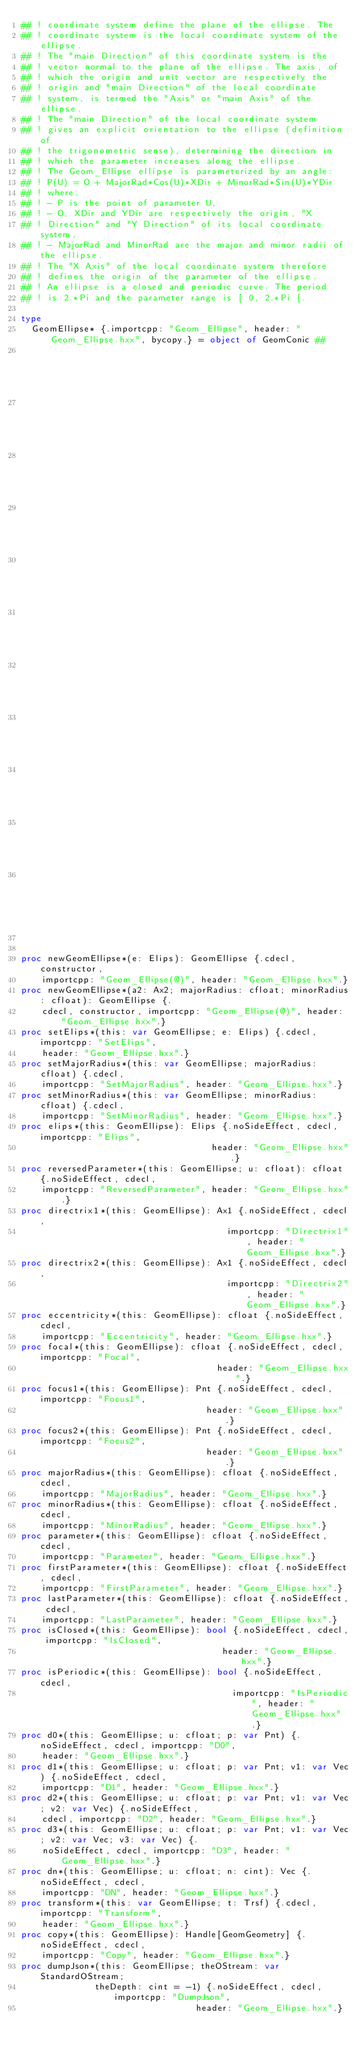<code> <loc_0><loc_0><loc_500><loc_500><_Nim_>## ! coordinate system define the plane of the ellipse. The
## ! coordinate system is the local coordinate system of the ellipse.
## ! The "main Direction" of this coordinate system is the
## ! vector normal to the plane of the ellipse. The axis, of
## ! which the origin and unit vector are respectively the
## ! origin and "main Direction" of the local coordinate
## ! system, is termed the "Axis" or "main Axis" of the ellipse.
## ! The "main Direction" of the local coordinate system
## ! gives an explicit orientation to the ellipse (definition of
## ! the trigonometric sense), determining the direction in
## ! which the parameter increases along the ellipse.
## ! The Geom_Ellipse ellipse is parameterized by an angle:
## ! P(U) = O + MajorRad*Cos(U)*XDir + MinorRad*Sin(U)*YDir
## ! where:
## ! - P is the point of parameter U,
## ! - O, XDir and YDir are respectively the origin, "X
## ! Direction" and "Y Direction" of its local coordinate system,
## ! - MajorRad and MinorRad are the major and minor radii of the ellipse.
## ! The "X Axis" of the local coordinate system therefore
## ! defines the origin of the parameter of the ellipse.
## ! An ellipse is a closed and periodic curve. The period
## ! is 2.*Pi and the parameter range is [ 0, 2.*Pi [.

type
  GeomEllipse* {.importcpp: "Geom_Ellipse", header: "Geom_Ellipse.hxx", bycopy.} = object of GeomConic ##
                                                                                             ## !
                                                                                             ## Constructs
                                                                                             ## an
                                                                                             ## ellipse
                                                                                             ## by
                                                                                             ## conversion
                                                                                             ## of
                                                                                             ## the
                                                                                             ## gp_Elips
                                                                                             ## ellipse
                                                                                             ## E.


proc newGeomEllipse*(e: Elips): GeomEllipse {.cdecl, constructor,
    importcpp: "Geom_Ellipse(@)", header: "Geom_Ellipse.hxx".}
proc newGeomEllipse*(a2: Ax2; majorRadius: cfloat; minorRadius: cfloat): GeomEllipse {.
    cdecl, constructor, importcpp: "Geom_Ellipse(@)", header: "Geom_Ellipse.hxx".}
proc setElips*(this: var GeomEllipse; e: Elips) {.cdecl, importcpp: "SetElips",
    header: "Geom_Ellipse.hxx".}
proc setMajorRadius*(this: var GeomEllipse; majorRadius: cfloat) {.cdecl,
    importcpp: "SetMajorRadius", header: "Geom_Ellipse.hxx".}
proc setMinorRadius*(this: var GeomEllipse; minorRadius: cfloat) {.cdecl,
    importcpp: "SetMinorRadius", header: "Geom_Ellipse.hxx".}
proc elips*(this: GeomEllipse): Elips {.noSideEffect, cdecl, importcpp: "Elips",
                                    header: "Geom_Ellipse.hxx".}
proc reversedParameter*(this: GeomEllipse; u: cfloat): cfloat {.noSideEffect, cdecl,
    importcpp: "ReversedParameter", header: "Geom_Ellipse.hxx".}
proc directrix1*(this: GeomEllipse): Ax1 {.noSideEffect, cdecl,
                                       importcpp: "Directrix1", header: "Geom_Ellipse.hxx".}
proc directrix2*(this: GeomEllipse): Ax1 {.noSideEffect, cdecl,
                                       importcpp: "Directrix2", header: "Geom_Ellipse.hxx".}
proc eccentricity*(this: GeomEllipse): cfloat {.noSideEffect, cdecl,
    importcpp: "Eccentricity", header: "Geom_Ellipse.hxx".}
proc focal*(this: GeomEllipse): cfloat {.noSideEffect, cdecl, importcpp: "Focal",
                                     header: "Geom_Ellipse.hxx".}
proc focus1*(this: GeomEllipse): Pnt {.noSideEffect, cdecl, importcpp: "Focus1",
                                   header: "Geom_Ellipse.hxx".}
proc focus2*(this: GeomEllipse): Pnt {.noSideEffect, cdecl, importcpp: "Focus2",
                                   header: "Geom_Ellipse.hxx".}
proc majorRadius*(this: GeomEllipse): cfloat {.noSideEffect, cdecl,
    importcpp: "MajorRadius", header: "Geom_Ellipse.hxx".}
proc minorRadius*(this: GeomEllipse): cfloat {.noSideEffect, cdecl,
    importcpp: "MinorRadius", header: "Geom_Ellipse.hxx".}
proc parameter*(this: GeomEllipse): cfloat {.noSideEffect, cdecl,
    importcpp: "Parameter", header: "Geom_Ellipse.hxx".}
proc firstParameter*(this: GeomEllipse): cfloat {.noSideEffect, cdecl,
    importcpp: "FirstParameter", header: "Geom_Ellipse.hxx".}
proc lastParameter*(this: GeomEllipse): cfloat {.noSideEffect, cdecl,
    importcpp: "LastParameter", header: "Geom_Ellipse.hxx".}
proc isClosed*(this: GeomEllipse): bool {.noSideEffect, cdecl, importcpp: "IsClosed",
                                      header: "Geom_Ellipse.hxx".}
proc isPeriodic*(this: GeomEllipse): bool {.noSideEffect, cdecl,
                                        importcpp: "IsPeriodic", header: "Geom_Ellipse.hxx".}
proc d0*(this: GeomEllipse; u: cfloat; p: var Pnt) {.noSideEffect, cdecl, importcpp: "D0",
    header: "Geom_Ellipse.hxx".}
proc d1*(this: GeomEllipse; u: cfloat; p: var Pnt; v1: var Vec) {.noSideEffect, cdecl,
    importcpp: "D1", header: "Geom_Ellipse.hxx".}
proc d2*(this: GeomEllipse; u: cfloat; p: var Pnt; v1: var Vec; v2: var Vec) {.noSideEffect,
    cdecl, importcpp: "D2", header: "Geom_Ellipse.hxx".}
proc d3*(this: GeomEllipse; u: cfloat; p: var Pnt; v1: var Vec; v2: var Vec; v3: var Vec) {.
    noSideEffect, cdecl, importcpp: "D3", header: "Geom_Ellipse.hxx".}
proc dn*(this: GeomEllipse; u: cfloat; n: cint): Vec {.noSideEffect, cdecl,
    importcpp: "DN", header: "Geom_Ellipse.hxx".}
proc transform*(this: var GeomEllipse; t: Trsf) {.cdecl, importcpp: "Transform",
    header: "Geom_Ellipse.hxx".}
proc copy*(this: GeomEllipse): Handle[GeomGeometry] {.noSideEffect, cdecl,
    importcpp: "Copy", header: "Geom_Ellipse.hxx".}
proc dumpJson*(this: GeomEllipse; theOStream: var StandardOStream;
              theDepth: cint = -1) {.noSideEffect, cdecl, importcpp: "DumpJson",
                                 header: "Geom_Ellipse.hxx".}</code> 